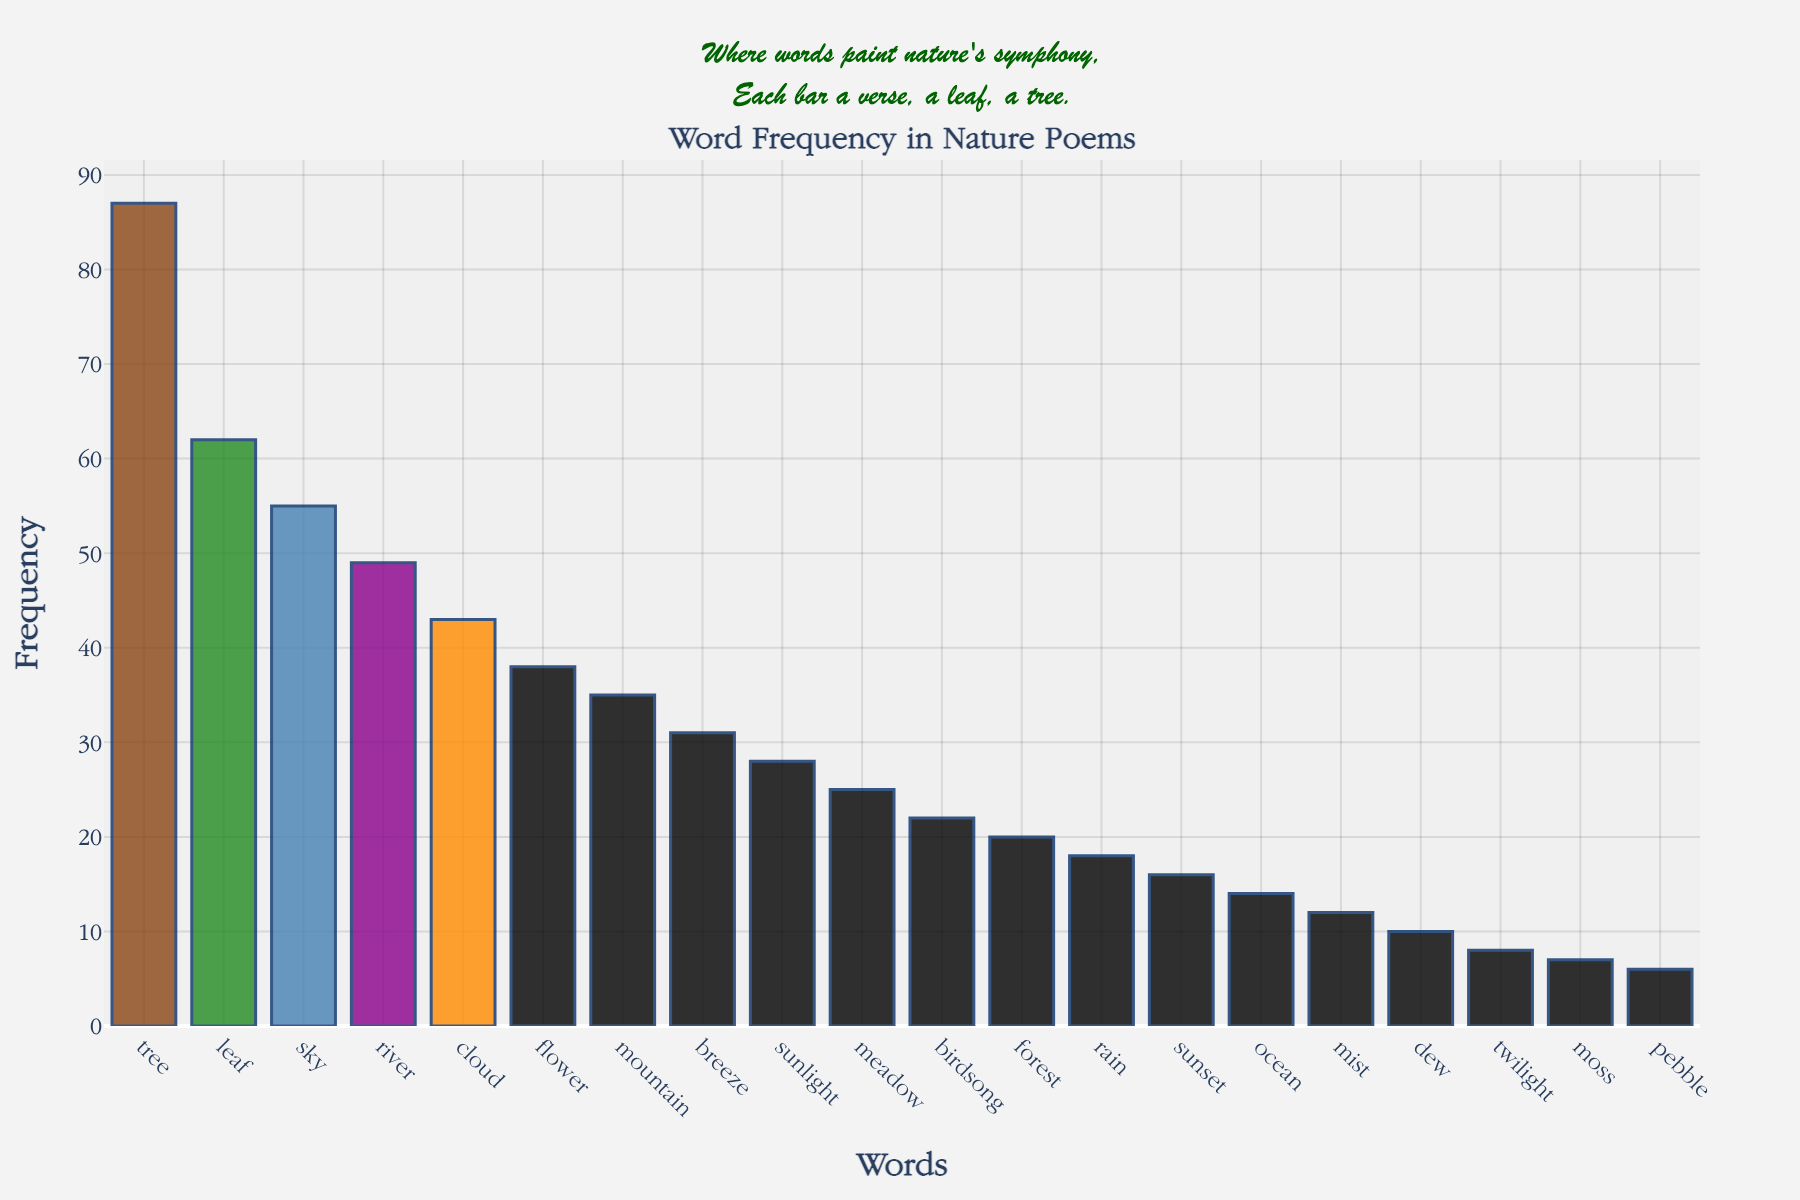What is the title of the histogram? The title is displayed at the top of the figure. It reads "<b>Word Frequency in Nature Poems</b>" which is formatted in bold.
Answer: Word Frequency in Nature Poems Which word has the highest frequency? To find this, look for the tallest bar in the histogram. The word corresponding to that bar is "tree" with a frequency of 87.
Answer: tree What are the colors used in the bars? The colors of the bars are displayed in shades of brown, green, blue, purple, and orange. These soft earth tones represent nature elements like wood, foliage, water, dusk, and sunlight.
Answer: Brown, Green, Blue, Purple, Orange Which words have a frequency greater than 50? The bars taller than 50 represent the words with frequencies greater than 50. These words are "tree," "leaf," and "sky."
Answer: tree, leaf, sky How many words have frequencies less than 20? Count the bars that are shorter than the 20 mark on the frequency axis. These bars include "rain," "sunset," "ocean," "mist," "dew," "twilight," "moss," and "pebble." There are 8 such words.
Answer: 8 What is the sum of the frequencies of the top three words? Identify the top three frequencies which are 87 (tree), 62 (leaf), and 55 (sky). Adding these values gives 87 + 62 + 55 = 204.
Answer: 204 Which word has the smallest frequency, and what is it? Look for the shortest bar in the histogram. The word corresponding to that bar is "pebble" with a frequency of 6.
Answer: pebble, 6 Compare the frequencies of "forest" and "meadow." Which one is more frequent, and by how much? Check the heights of the bars for "forest" (20) and "meadow" (25). "meadow" is more frequent than "forest" by 25 - 20 = 5.
Answer: meadow, 5 What is the average frequency of "mountain," "breeze," and "sunlight"? Find their frequencies: "mountain" (35), "breeze" (31), "sunlight" (28). Calculate the average: (35 + 31 + 28) / 3 = 94 / 3 ≈ 31.33.
Answer: 31.33 